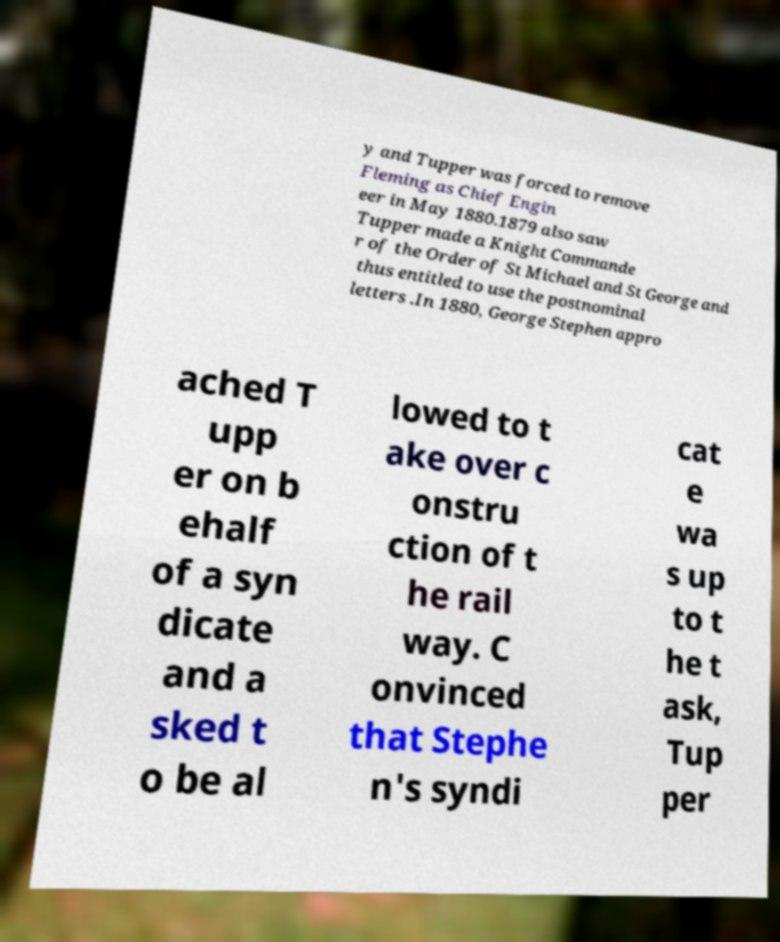There's text embedded in this image that I need extracted. Can you transcribe it verbatim? y and Tupper was forced to remove Fleming as Chief Engin eer in May 1880.1879 also saw Tupper made a Knight Commande r of the Order of St Michael and St George and thus entitled to use the postnominal letters .In 1880, George Stephen appro ached T upp er on b ehalf of a syn dicate and a sked t o be al lowed to t ake over c onstru ction of t he rail way. C onvinced that Stephe n's syndi cat e wa s up to t he t ask, Tup per 